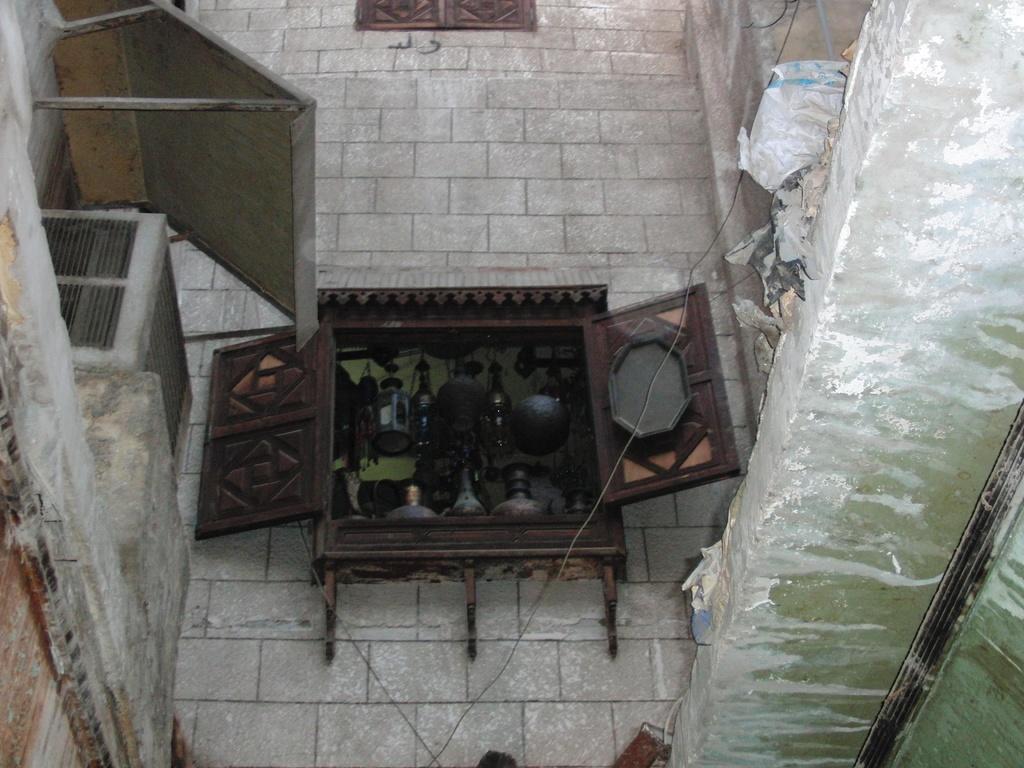How would you summarize this image in a sentence or two? In the center of the picture it is wall, to the wall there are windows, through the windows we can see some kitchen utensils. On the left there are air conditioner, roof and wall. On the right it is well. At the bottom there are cables. 